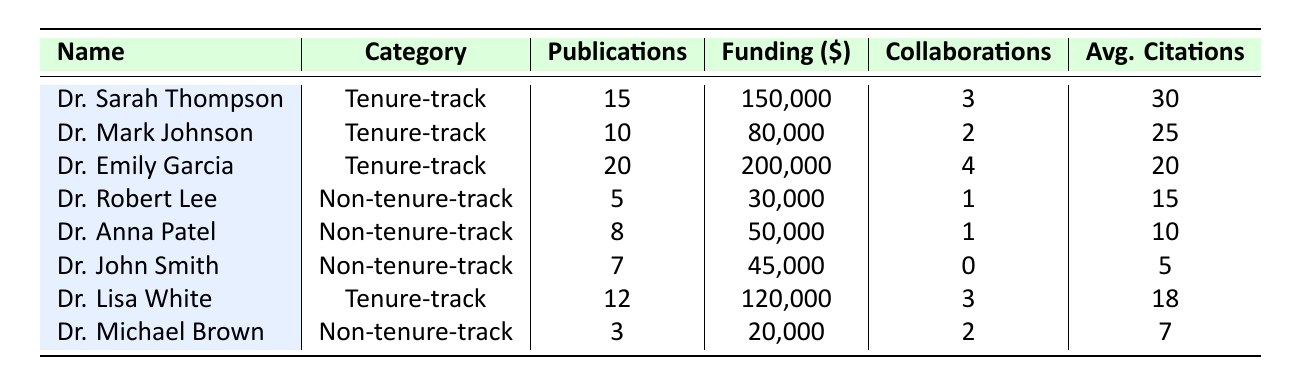What is the total number of publications by tenure-track faculty? The publications for tenure-track faculty are: Dr. Sarah Thompson (15), Dr. Mark Johnson (10), Dr. Emily Garcia (20), and Dr. Lisa White (12). Summing these gives 15 + 10 + 20 + 12 = 57.
Answer: 57 Which non-tenure-track faculty member has the highest average citations per publication? The average citations for non-tenure-track faculty are: Dr. Robert Lee (15), Dr. Anna Patel (10), Dr. John Smith (5), and Dr. Michael Brown (7). The highest is Dr. Robert Lee with 15 citations.
Answer: Dr. Robert Lee Does Dr. Emily Garcia have more collaborative projects than Dr. Sarah Thompson? Dr. Emily Garcia has 4 collaborative projects while Dr. Sarah Thompson has 3. Since 4 is greater than 3, the statement is true.
Answer: Yes What is the average funding amount for non-tenure-track faculty? The funding amounts for non-tenure-track faculty are: Dr. Robert Lee (30,000), Dr. Anna Patel (50,000), Dr. John Smith (45,000), and Dr. Michael Brown (20,000). Summing these gives 30,000 + 50,000 + 45,000 + 20,000 = 145,000. Dividing by 4 gives an average of 145,000 / 4 = 36,250.
Answer: 36,250 Which faculty category has a higher total funding amount? Total funding for tenure-track faculty is: 150,000 + 80,000 + 200,000 + 120,000 = 550,000. For non-tenure-track faculty, the total is: 30,000 + 50,000 + 45,000 + 20,000 = 145,000. Since 550,000 is greater than 145,000, tenure-track faculty has higher funding.
Answer: Tenure-track What is the difference in total publications between tenure-track and non-tenure-track faculty? Total publications for tenure-track faculty are 57 (as calculated earlier) and for non-tenure-track faculty, they are: 5 + 8 + 7 + 3 = 23. The difference is 57 - 23 = 34.
Answer: 34 